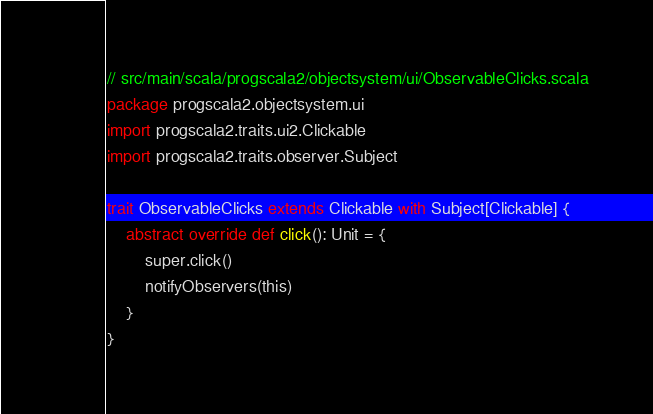<code> <loc_0><loc_0><loc_500><loc_500><_Scala_>// src/main/scala/progscala2/objectsystem/ui/ObservableClicks.scala
package progscala2.objectsystem.ui
import progscala2.traits.ui2.Clickable
import progscala2.traits.observer.Subject

trait ObservableClicks extends Clickable with Subject[Clickable] {
    abstract override def click(): Unit = {
        super.click()
        notifyObservers(this)
    }
}
</code> 